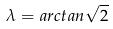Convert formula to latex. <formula><loc_0><loc_0><loc_500><loc_500>\lambda = a r c t a n \sqrt { 2 }</formula> 